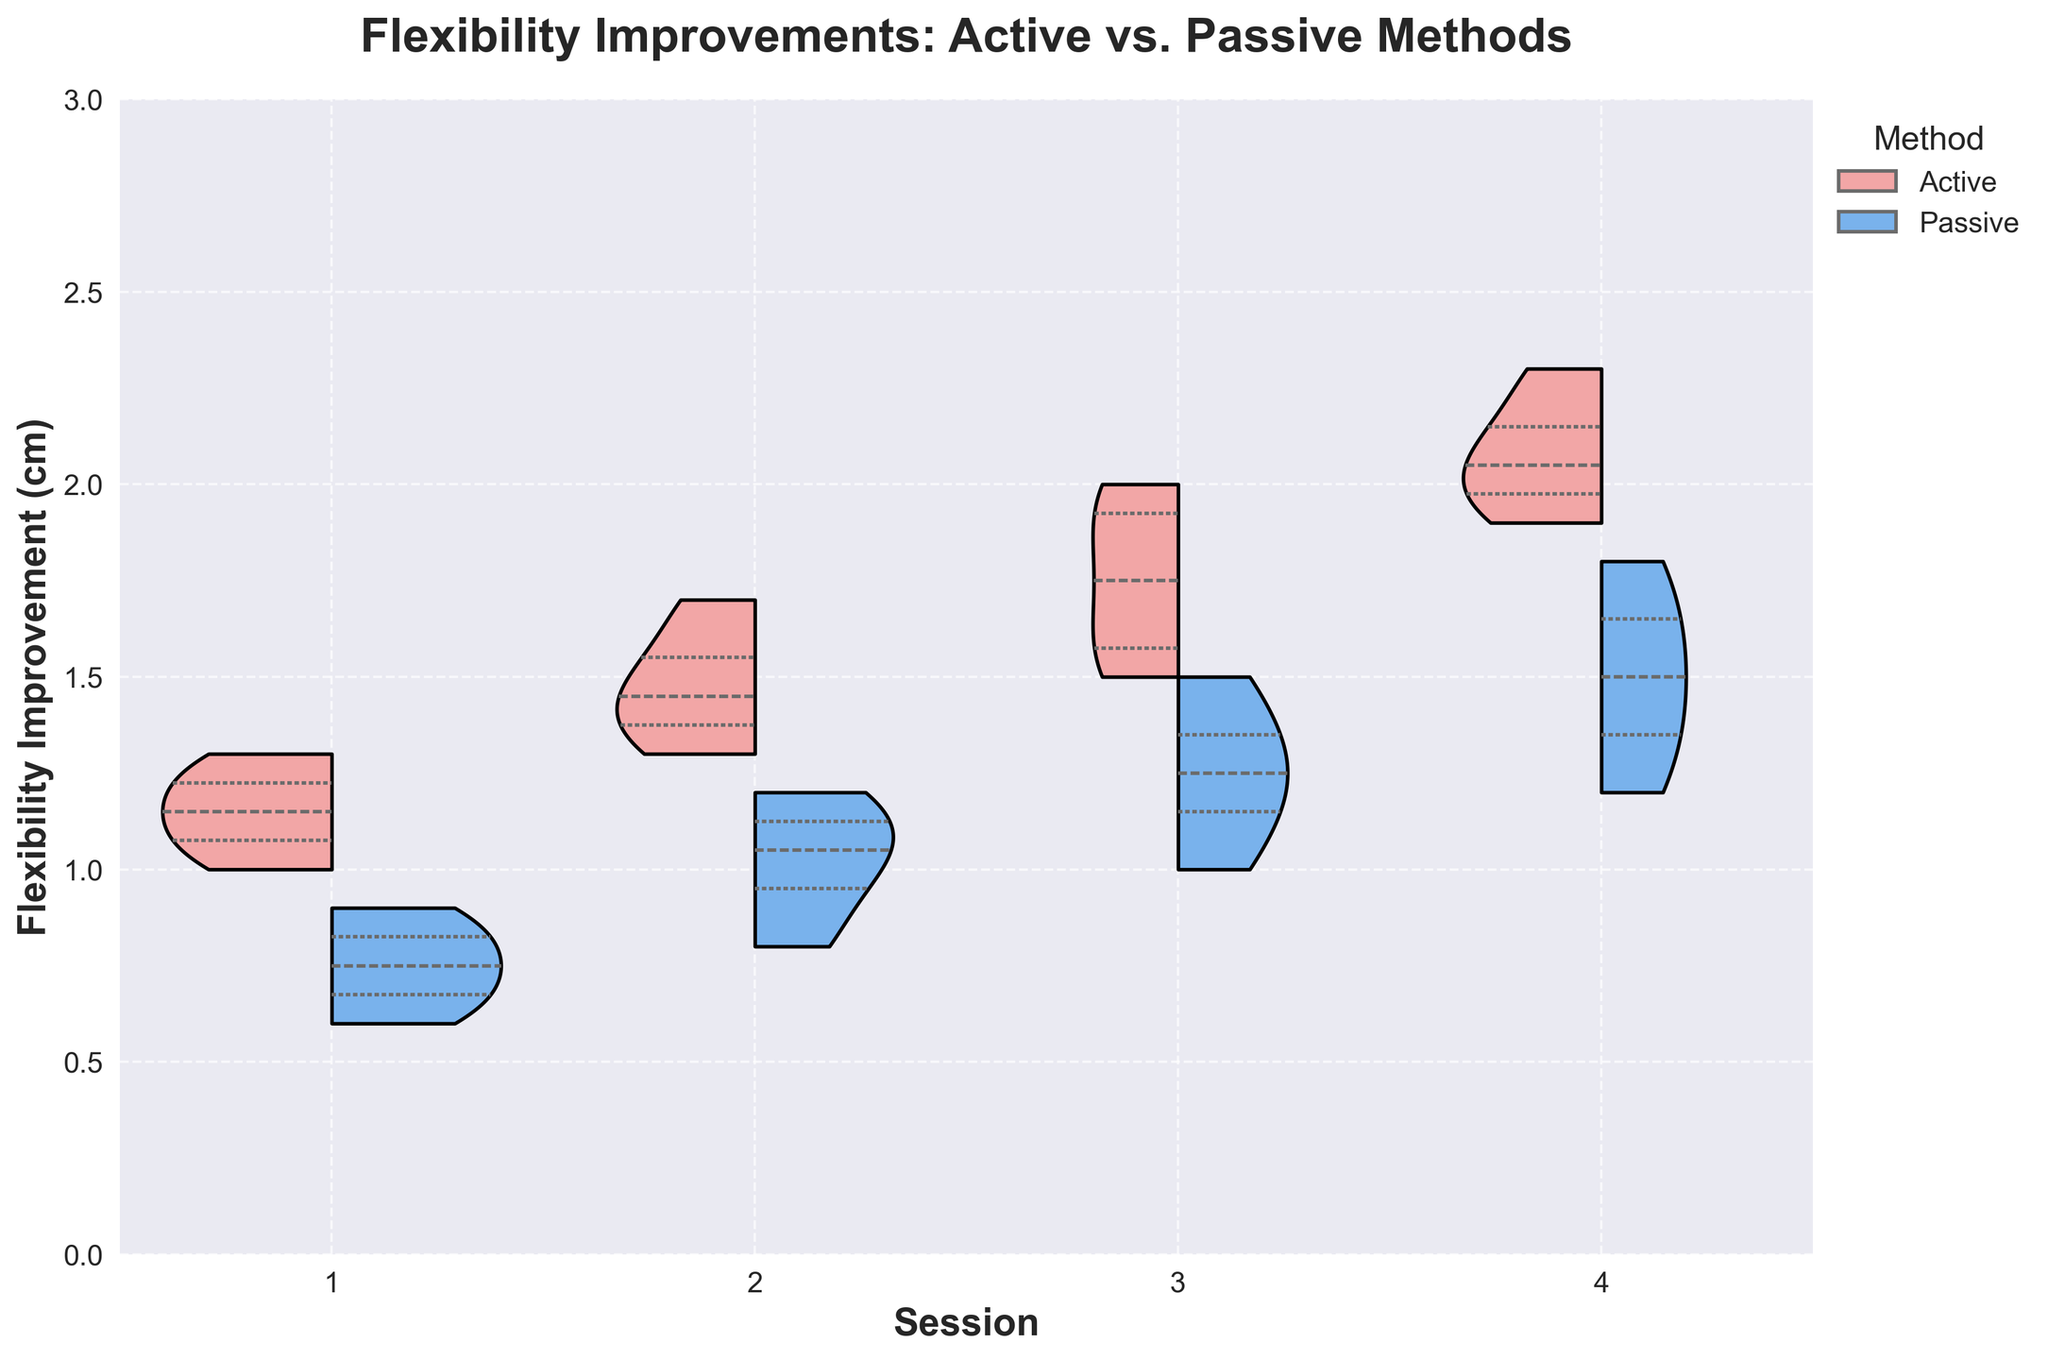What is the title of the chart? The title of the chart is located at the top of the figure and provides an overview of the data being displayed. It reads: "Flexibility Improvements: Active vs. Passive Methods".
Answer: Flexibility Improvements: Active vs. Passive Methods How many sessions are displayed in the chart? The x-axis of the chart represents the sessions, and there are four labeled sessions: 1, 2, 3, and 4.
Answer: 4 What are the ranges of flexibility improvement values for the Active method in Session 1? The flexibility improvement values for the Active method in Session 1 are shown in the left half of the first violin plot (labeled "1" on the x-axis). These values range approximately from 1.0 to 1.3 cm.
Answer: 1.0 to 1.3 cm Which method shows a higher median flexibility improvement in Session 4? The violin plot includes inner quartiles which show the median values. Observing the violin plot for Session 4, the Active method (left side of the plot) shows a higher median compared to the Passive method (right side).
Answer: Active In which session does the Passive method demonstrate the greatest increase in flexibility improvement? By examining the violin plots for all sessions and comparing the range and median of the Passive method (right side of each plot), it is clear that Session 4 shows the highest median improvement for the Passive method.
Answer: Session 4 What is the difference in median flexibility improvement between Active and Passive methods in Session 3? To find this, we locate the medians in Session 3 for both methods within the inner quartiles. The difference is calculated by subtracting the Passive method's median from the Active method's median. The Active method is approximately 1.7 cm, and the Passive method is approximately 1.25 cm, so the difference is 1.7 cm - 1.25 cm.
Answer: 0.45 cm How does the distribution of flexibility improvement for the Active method in Session 2 compare to the Passive method in the same session? Comparing the violin plots for Session 2, observe the shape and spread of each method's distribution. The Active method shows a slightly wider and higher range of flexibility improvement values compared to the Passive method, indicating higher overall improvement.
Answer: Active method is wider and higher What is the maximum flexibility improvement observed in any session for both methods combined? Maximum flexibility improvement for each method is seen at the top of the respective violin plots. By examining all sessions, the maximum value appears to be for the Active method in Session 4, which approaches 2.3 cm.
Answer: 2.3 cm Do both methods exhibit a consistent trend of increasing flexibility improvement across sessions? By inspecting the quartile lines and overall shapes of the violin plots across all sessions for both methods, we observe that both methods show a general trend of increasing flexibility improvement from Session 1 to Session 4.
Answer: Yes 